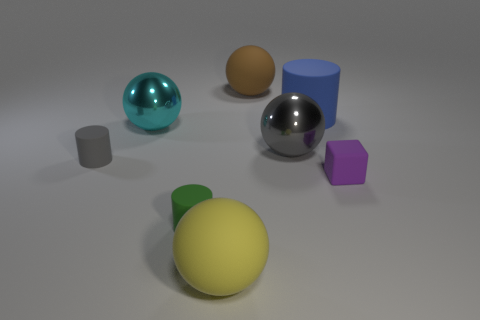What number of gray objects are small rubber objects or matte balls?
Provide a short and direct response. 1. What number of other things have the same size as the cyan shiny thing?
Provide a short and direct response. 4. There is a large object that is both behind the small purple thing and in front of the big cyan shiny sphere; what color is it?
Your answer should be very brief. Gray. Are there more small green matte cylinders right of the large gray ball than matte objects?
Your answer should be very brief. No. Is there a small brown object?
Ensure brevity in your answer.  No. Does the cube have the same color as the large cylinder?
Give a very brief answer. No. What number of large objects are either brown metal things or green objects?
Ensure brevity in your answer.  0. Is there anything else of the same color as the matte cube?
Provide a short and direct response. No. What is the shape of the gray thing that is the same material as the cyan thing?
Your answer should be compact. Sphere. How big is the matte ball left of the large brown ball?
Ensure brevity in your answer.  Large. 